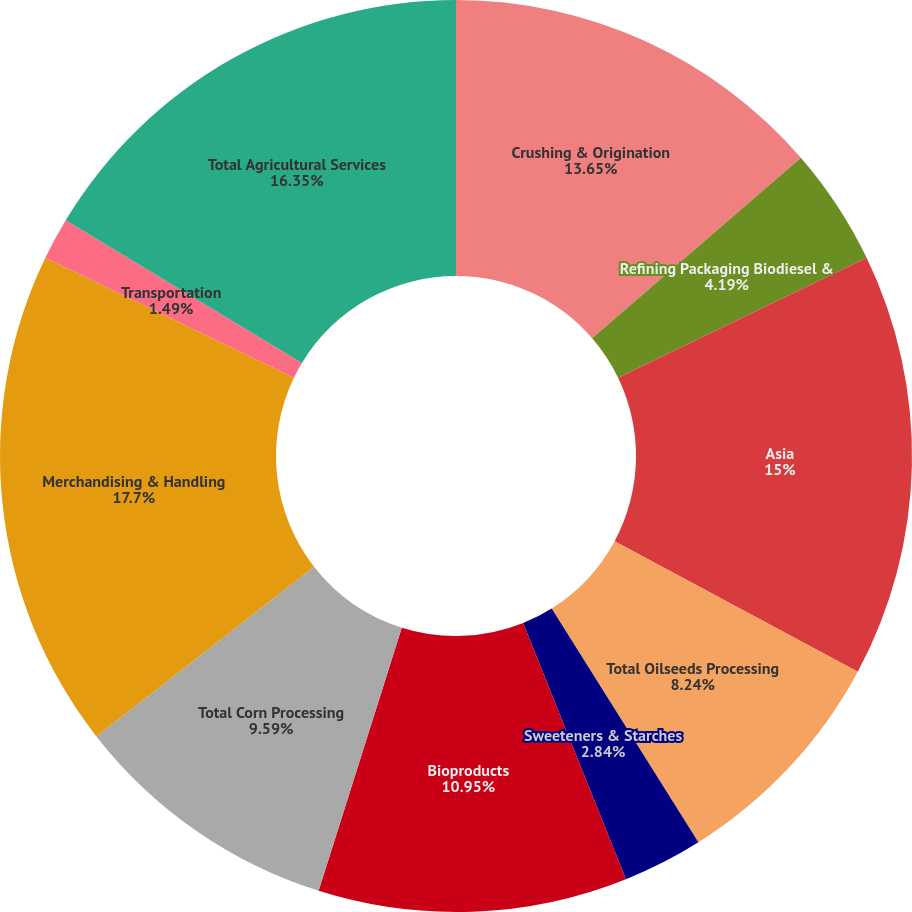<chart> <loc_0><loc_0><loc_500><loc_500><pie_chart><fcel>Crushing & Origination<fcel>Refining Packaging Biodiesel &<fcel>Asia<fcel>Total Oilseeds Processing<fcel>Sweeteners & Starches<fcel>Bioproducts<fcel>Total Corn Processing<fcel>Merchandising & Handling<fcel>Transportation<fcel>Total Agricultural Services<nl><fcel>13.65%<fcel>4.19%<fcel>15.0%<fcel>8.24%<fcel>2.84%<fcel>10.95%<fcel>9.59%<fcel>17.7%<fcel>1.49%<fcel>16.35%<nl></chart> 